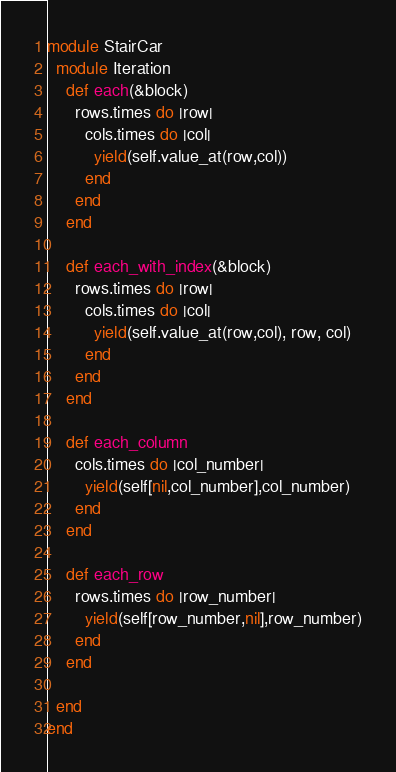<code> <loc_0><loc_0><loc_500><loc_500><_Ruby_>module StairCar
  module Iteration
    def each(&block)
      rows.times do |row|
        cols.times do |col|
          yield(self.value_at(row,col))
        end
      end
    end

    def each_with_index(&block)
      rows.times do |row|
        cols.times do |col|
          yield(self.value_at(row,col), row, col)
        end
      end
    end

    def each_column
      cols.times do |col_number|
        yield(self[nil,col_number],col_number)
      end
    end

    def each_row
      rows.times do |row_number|
        yield(self[row_number,nil],row_number)
      end
    end

  end
end</code> 